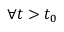Convert formula to latex. <formula><loc_0><loc_0><loc_500><loc_500>\forall t > t _ { 0 }</formula> 